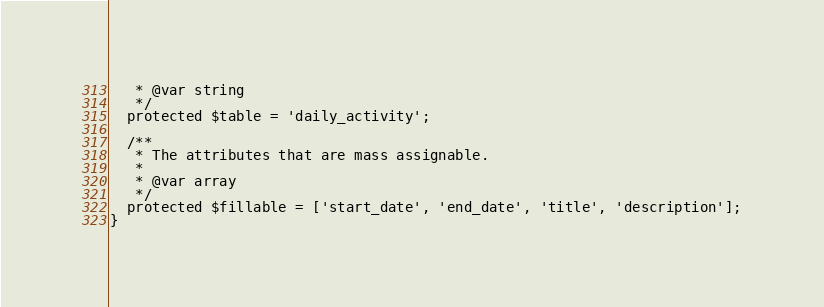Convert code to text. <code><loc_0><loc_0><loc_500><loc_500><_PHP_>   * @var string 
   */
  protected $table = 'daily_activity';

  /**
   * The attributes that are mass assignable.
   *
   * @var array
   */
  protected $fillable = ['start_date', 'end_date', 'title', 'description'];
}
</code> 